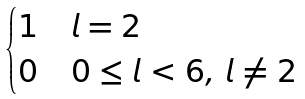Convert formula to latex. <formula><loc_0><loc_0><loc_500><loc_500>\begin{cases} 1 & l = 2 \\ 0 & 0 \leq l < 6 , \, l \neq 2 \end{cases}</formula> 